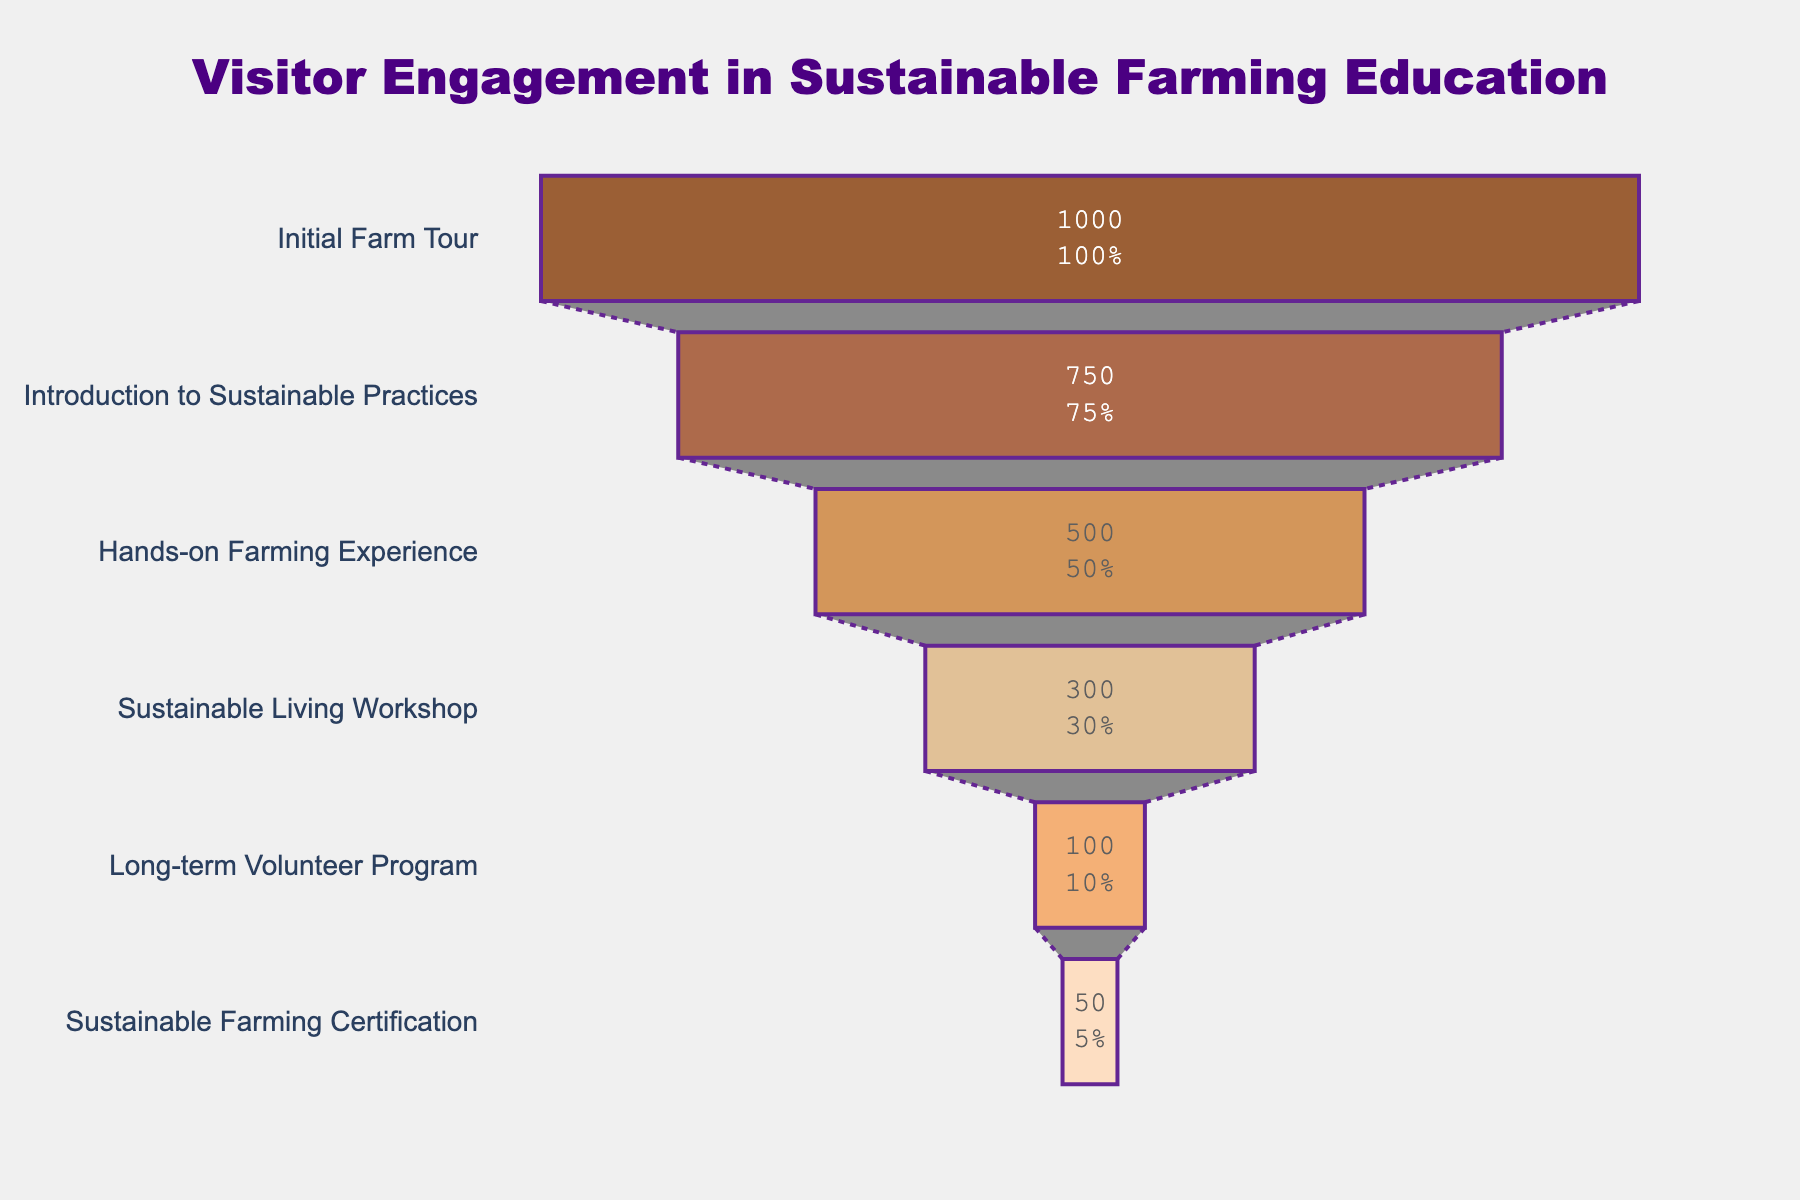How many visitors participated in the Long-term Volunteer Program? Look at the section labeled "Long-term Volunteer Program" and check the number of visitors.
Answer: 100 What percentage of visitors attended the Hands-on Farming Experience stage? Find the section labeled "Hands-on Farming Experience." The percentage is shown inside each section on the chart.
Answer: 50% How many fewer visitors attended the Sustainable Living Workshop compared to the Introduction to Sustainable Practices? Find the number of visitors for both "Sustainable Living Workshop" (300) and "Introduction to Sustainable Practices" (750), then subtract the former from the latter (750 - 300).
Answer: 450 Which engagement stage had the highest number of visitors? Look at the funnel chart and find the largest section, which is the initial stage of the chart.
Answer: Initial Farm Tour What is the difference in visitor numbers between the first and last stages? Find the number of visitors for "Initial Farm Tour" (1000) and "Sustainable Farming Certification" (50), then subtract the latter from the former (1000 - 50).
Answer: 950 What stage follows the Hands-on Farming Experience in the funnel chart? Identify the section labeled "Hands-on Farming Experience" and see the section that comes immediately after it.
Answer: Sustainable Living Workshop What is the total number of visitors at the Hands-on Farming Experience and Sustainable Living Workshop stages combined? Find the visitor numbers for "Hands-on Farming Experience" (500) and "Sustainable Living Workshop" (300), then add them together (500 + 300).
Answer: 800 Is the percentage retention higher at the Introduction to Sustainable Practices stage or the Hands-on Farming Experience stage? Check the percentage values for both stages shown inside their respective sections. Compare 75% for "Introduction to Sustainable Practices" with 50% for "Hands-on Farming Experience."
Answer: Introduction to Sustainable Practices How many visitors completed the Sustainable Farming Certification stage? Look at the section labeled "Sustainable Farming Certification" and check the number of visitors.
Answer: 50 Which stage has approximately one-third of the visitors compared to the Initial Farm Tour? Compare the sections and find "Hands-on Farming Experience," which has 500 visitors. 500 is approximately one-third of 1000 (Initial Farm Tour visitors).
Answer: Hands-on Farming Experience 